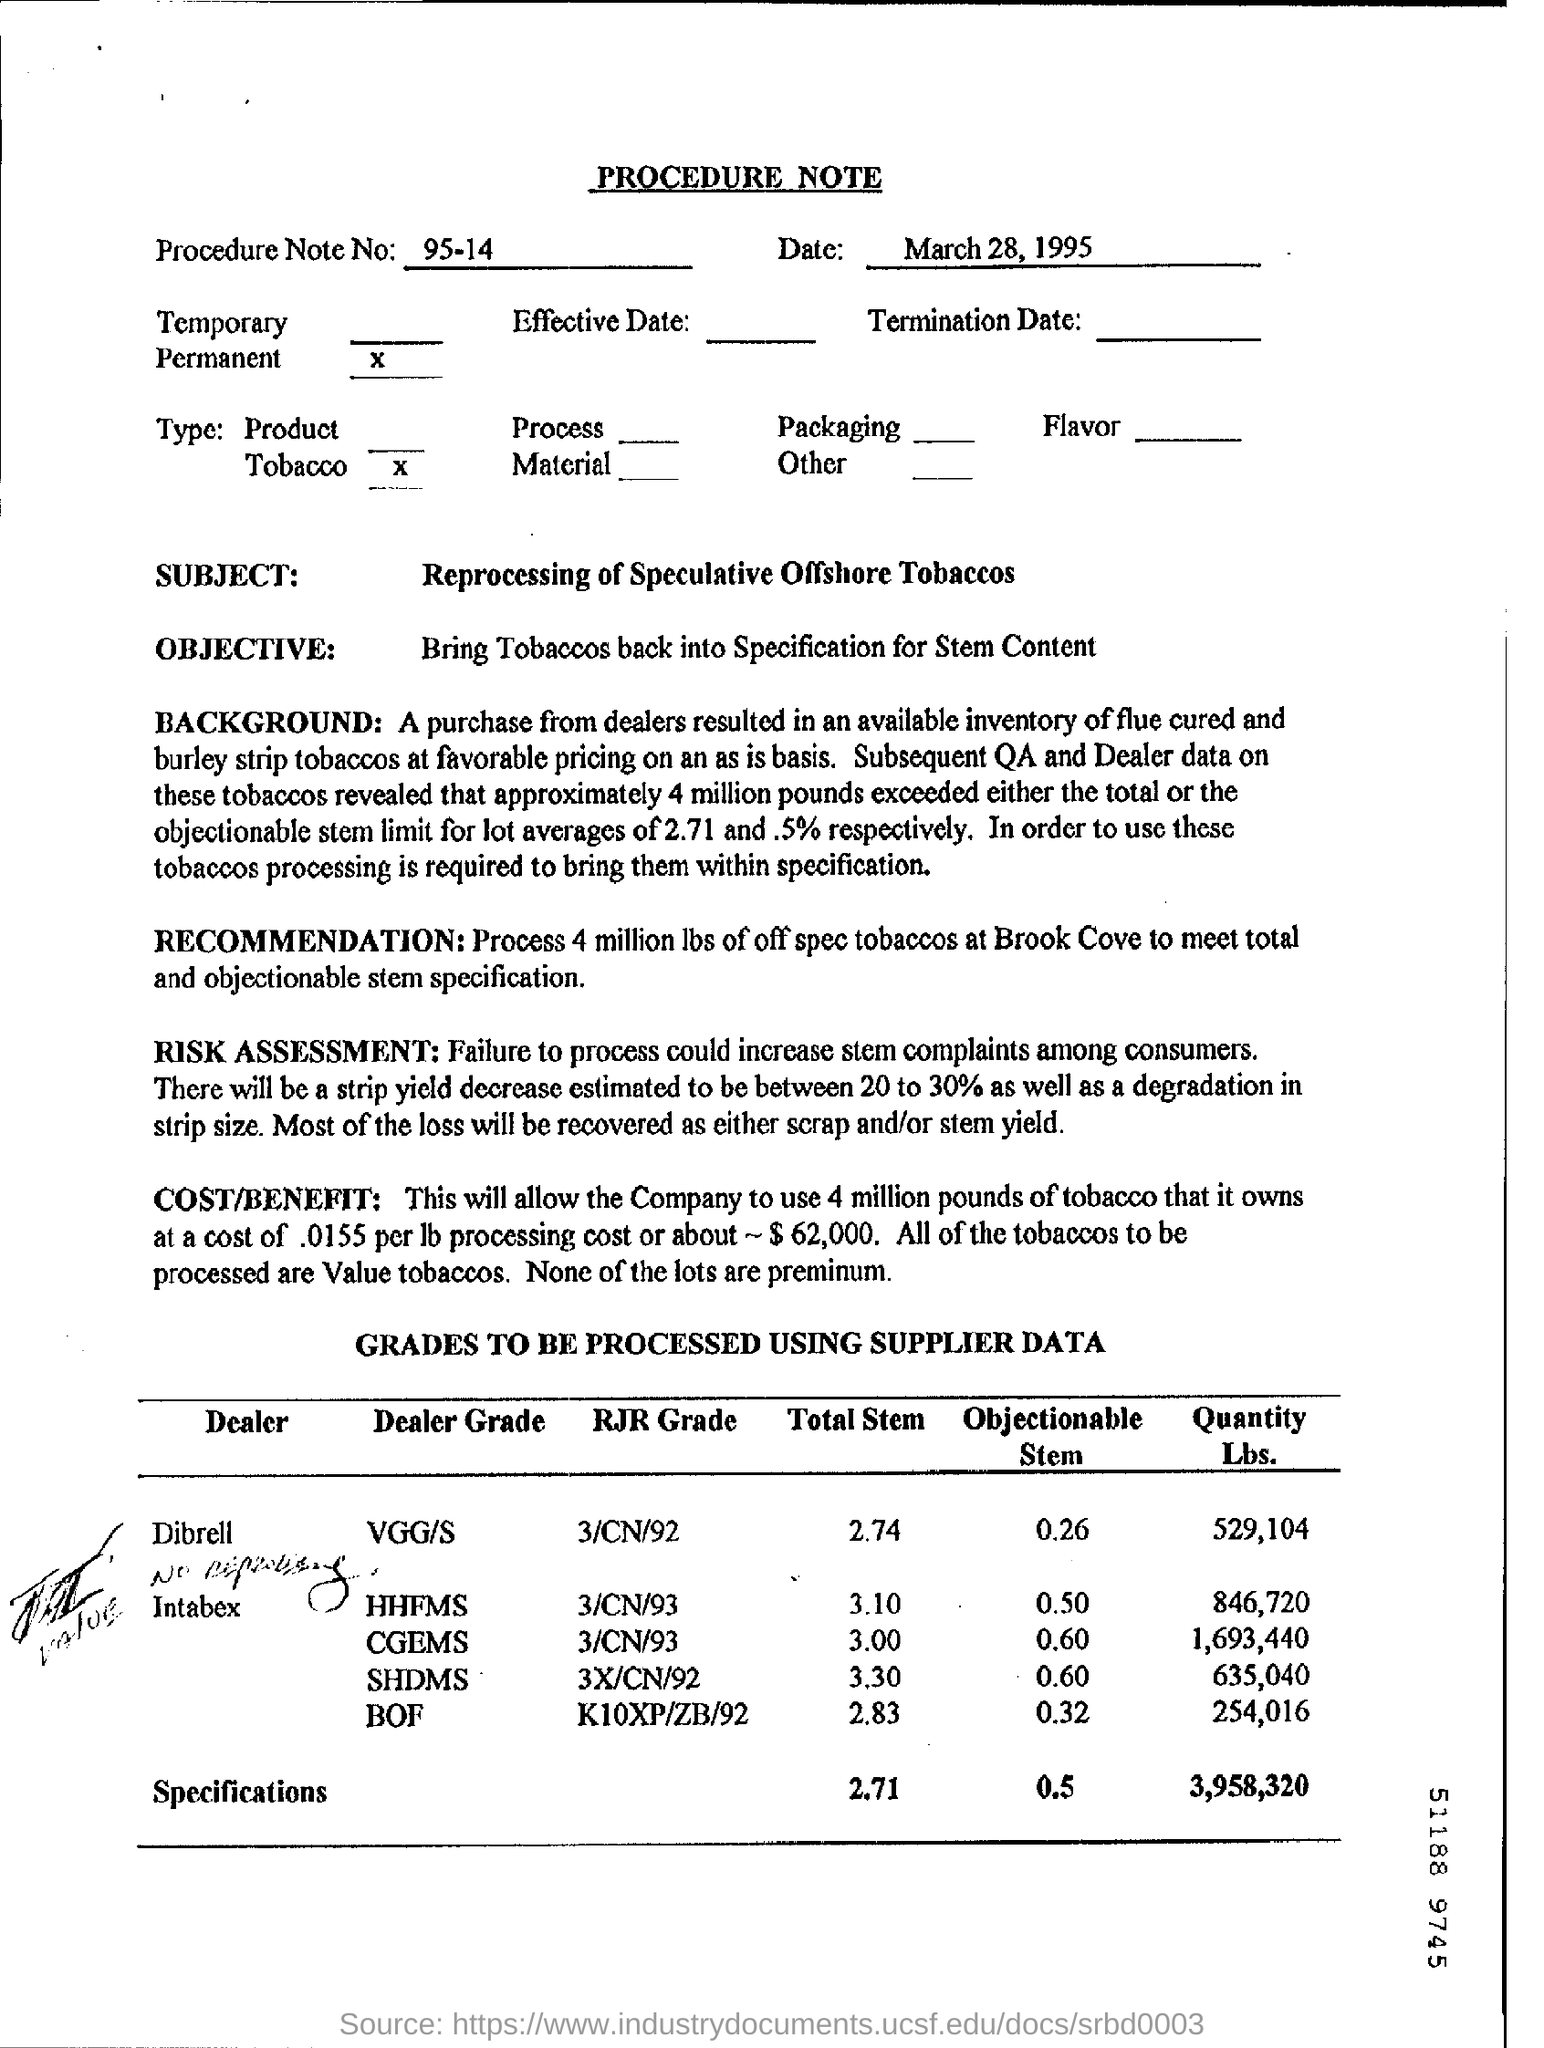What is the 'subject' of the procedure note ?
Your answer should be very brief. Reprocessing of Speculative Offshore Tobaccos. What is the 'Objective' of Procedure Note ?
Ensure brevity in your answer.  Bring Tobaccos back into Specification for Stem Content. At which place is it recommended to process the tobaccos?
Your answer should be very brief. Brook Cove. When is the procedure note dated?
Offer a terse response. March 28, 1995. Which dealer has 529,104 lbs of tobacco to be processed?
Provide a short and direct response. Dibrell. What can happen if there is a failure to process?
Provide a succinct answer. Failure to process could increase stem complaints among customers. What percentage is the strip yield decrease estimated?
Provide a short and direct response. 20 to 30%. 